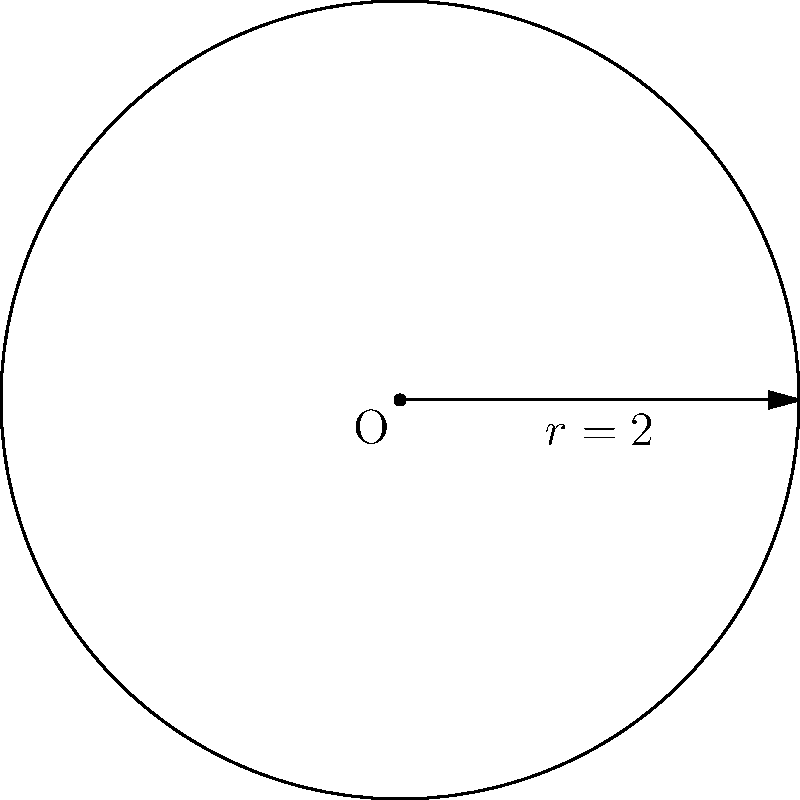As a former loyal customer of Lo Scalco, you recall their signature circular dining tables. The radius of these tables can be described in polar form as $r(\theta) = 2$ (in meters) for all $\theta$. What is the area of one of these tables in square meters? To find the area of the circular table described in polar form, we can follow these steps:

1) The general formula for the area of a region in polar coordinates is:

   $$A = \frac{1}{2} \int_{0}^{2\pi} [r(\theta)]^2 d\theta$$

2) In this case, $r(\theta) = 2$ for all $\theta$, so we can substitute this into our formula:

   $$A = \frac{1}{2} \int_{0}^{2\pi} 2^2 d\theta$$

3) Simplify the integrand:

   $$A = \frac{1}{2} \int_{0}^{2\pi} 4 d\theta$$

4) The integral of a constant is the constant times the variable:

   $$A = \frac{1}{2} [4\theta]_{0}^{2\pi}$$

5) Evaluate the integral:

   $$A = \frac{1}{2} [4(2\pi) - 4(0)] = \frac{1}{2} (8\pi)$$

6) Simplify:

   $$A = 4\pi$$

Therefore, the area of one of Lo Scalco's circular dining tables is $4\pi$ square meters.
Answer: $4\pi$ square meters 